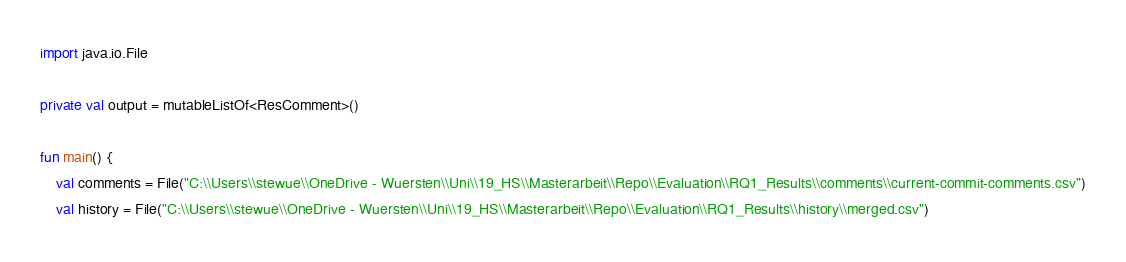Convert code to text. <code><loc_0><loc_0><loc_500><loc_500><_Kotlin_>import java.io.File

private val output = mutableListOf<ResComment>()

fun main() {
    val comments = File("C:\\Users\\stewue\\OneDrive - Wuersten\\Uni\\19_HS\\Masterarbeit\\Repo\\Evaluation\\RQ1_Results\\comments\\current-commit-comments.csv")
    val history = File("C:\\Users\\stewue\\OneDrive - Wuersten\\Uni\\19_HS\\Masterarbeit\\Repo\\Evaluation\\RQ1_Results\\history\\merged.csv")</code> 